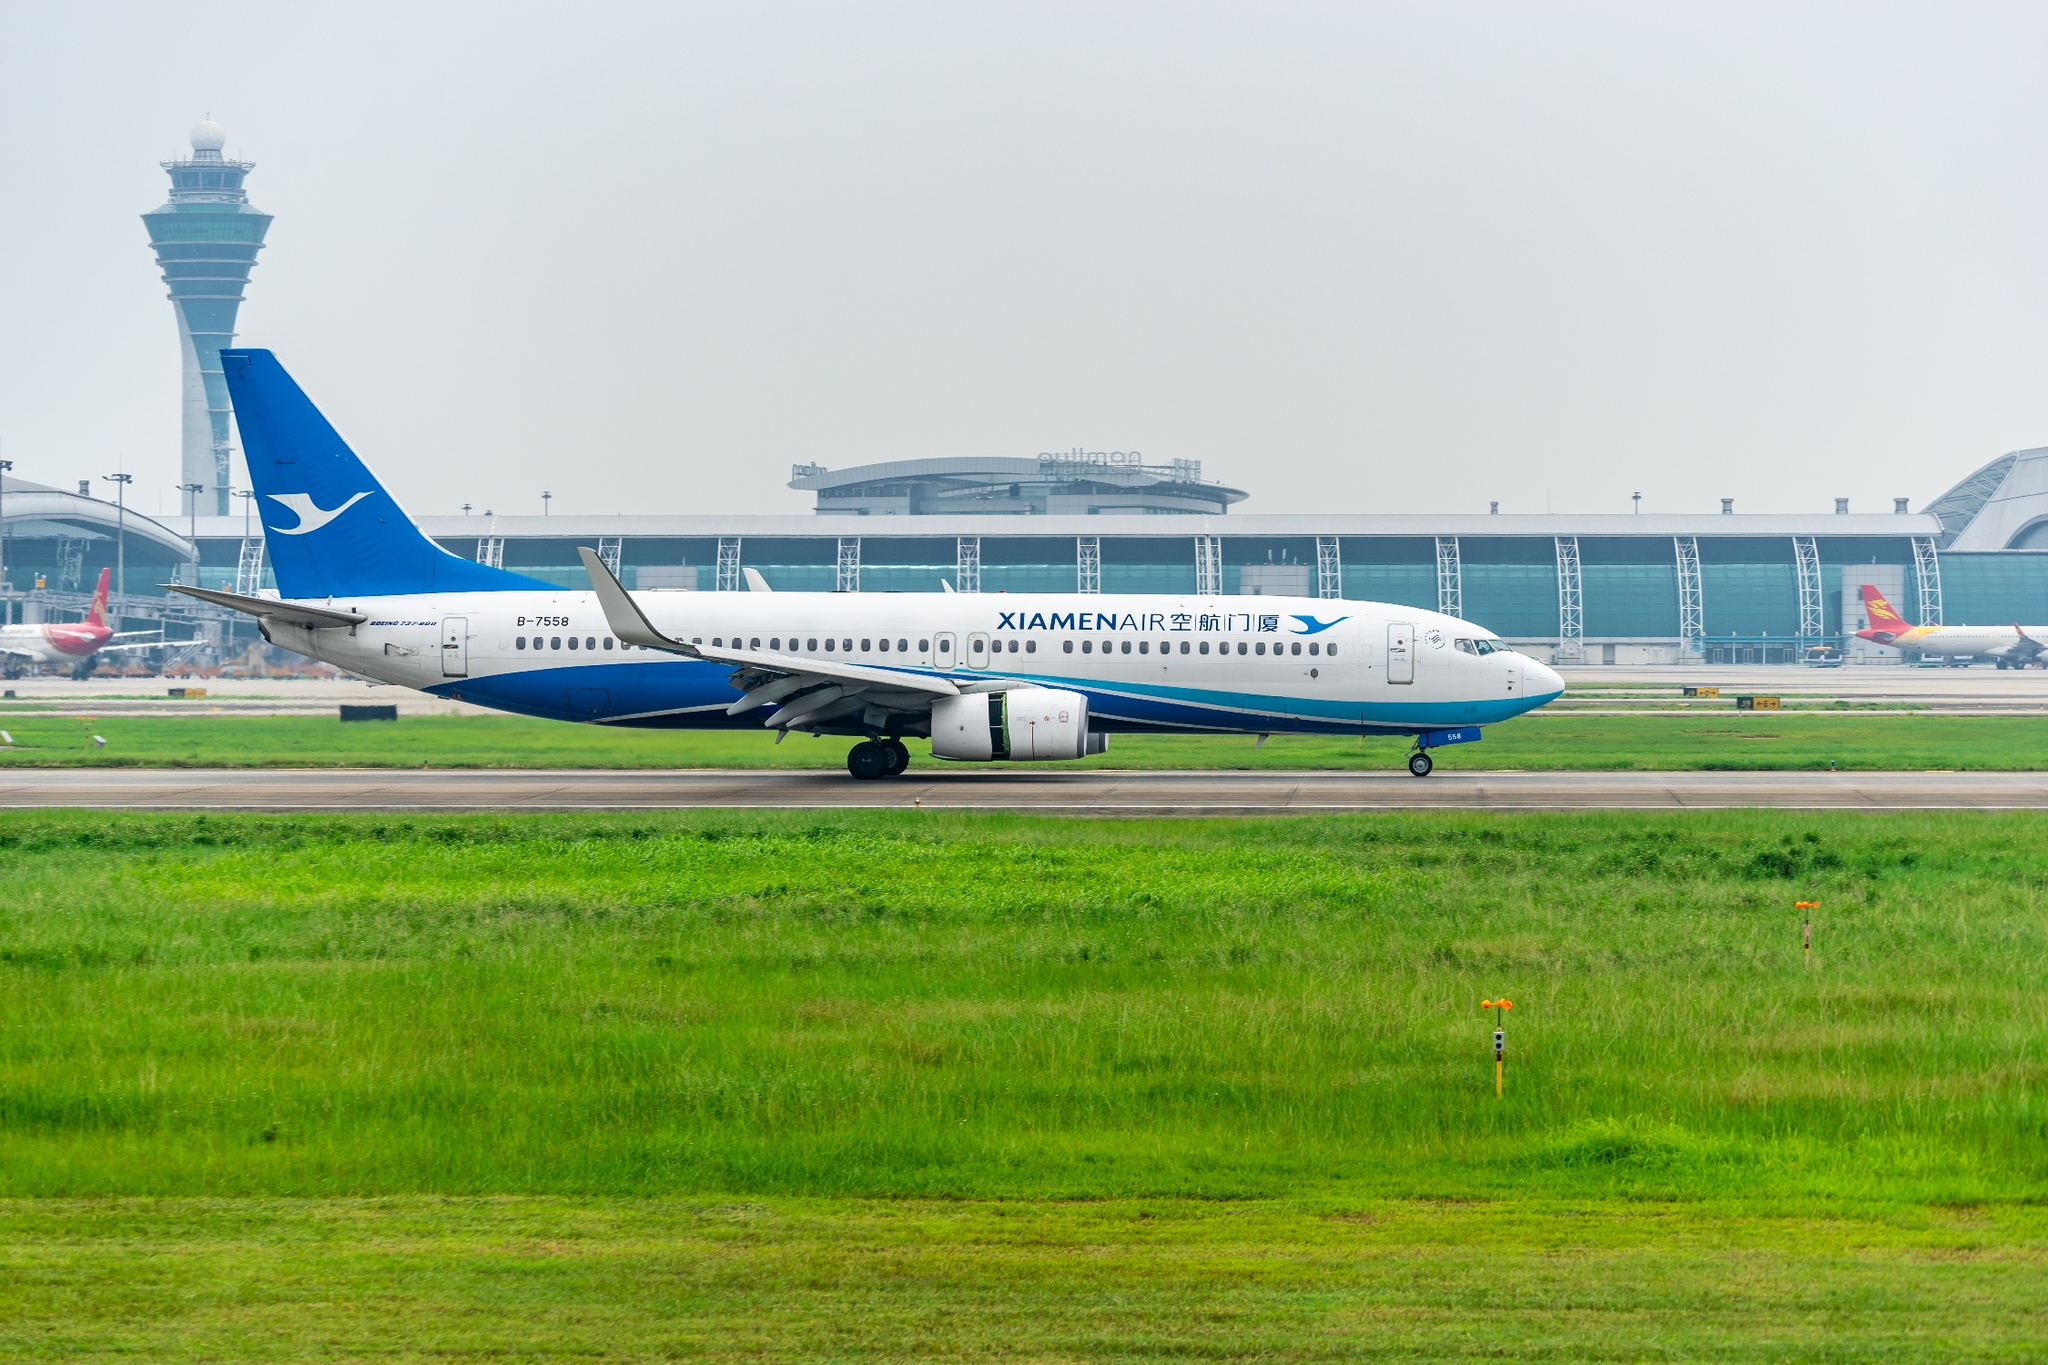Describe the surroundings and activities visible around the airplane. Around the XiamenAir airplane, the airport terminal is visible in the background, characterized by its modern design and large glass windows. Various airport operations are ongoing, with other airplanes from different airlines stationed near the terminal gates. The control tower is overseeing the runway activities, ensuring the safe movement of all aircraft. Grass and taxi lights in the foreground add a touch of greenery to the scene, contrasting with the industrial feel of the airport structures. What kind of preparations might be going on inside the terminal for departing flights? Inside the terminal, various preparations for departing flights are likely underway. Passengers might be checking in at the airline counters, dropping off their luggage, or clearing security checkpoints. Airport staff are coordinating boarding processes, ensuring that passengers have their boarding passes and are directed to the correct gates. Retail and food establishments within the terminal are serving travelers, while cleaning teams maintain the terminal's cleanliness. The hustle and bustle within the terminal reflect the complex coordination required for efficient air travel operations. 